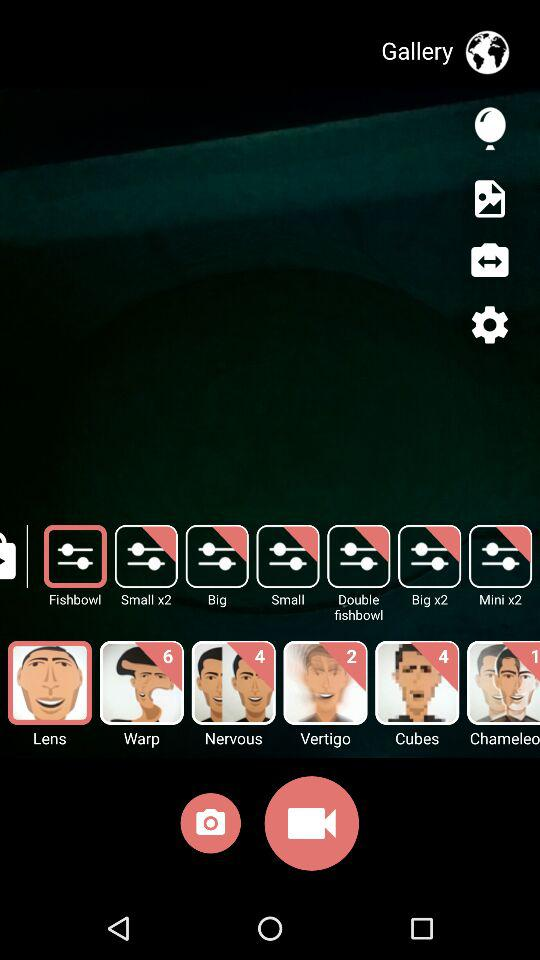How many new features are available for the "Nervous" option? There are 4 new features available for the "Nervous" option. 